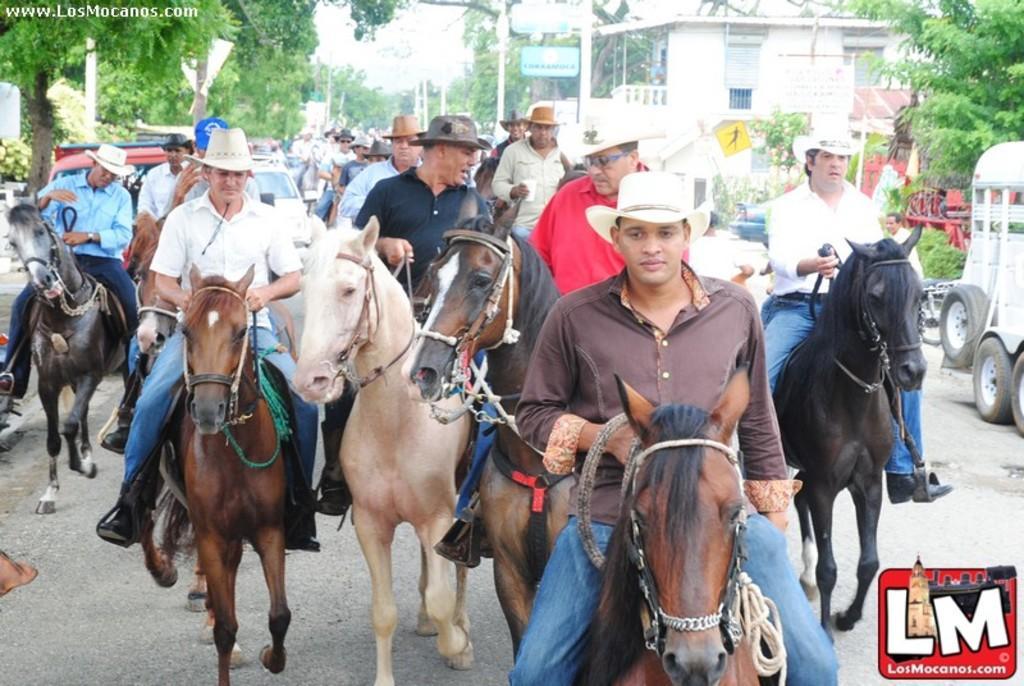How would you summarize this image in a sentence or two? In this image in front there are people sitting on the horses. There are vehicles on the road. In the background of the image there are trees, buildings, street lights and sky. There is a logo on the right side of the image. 